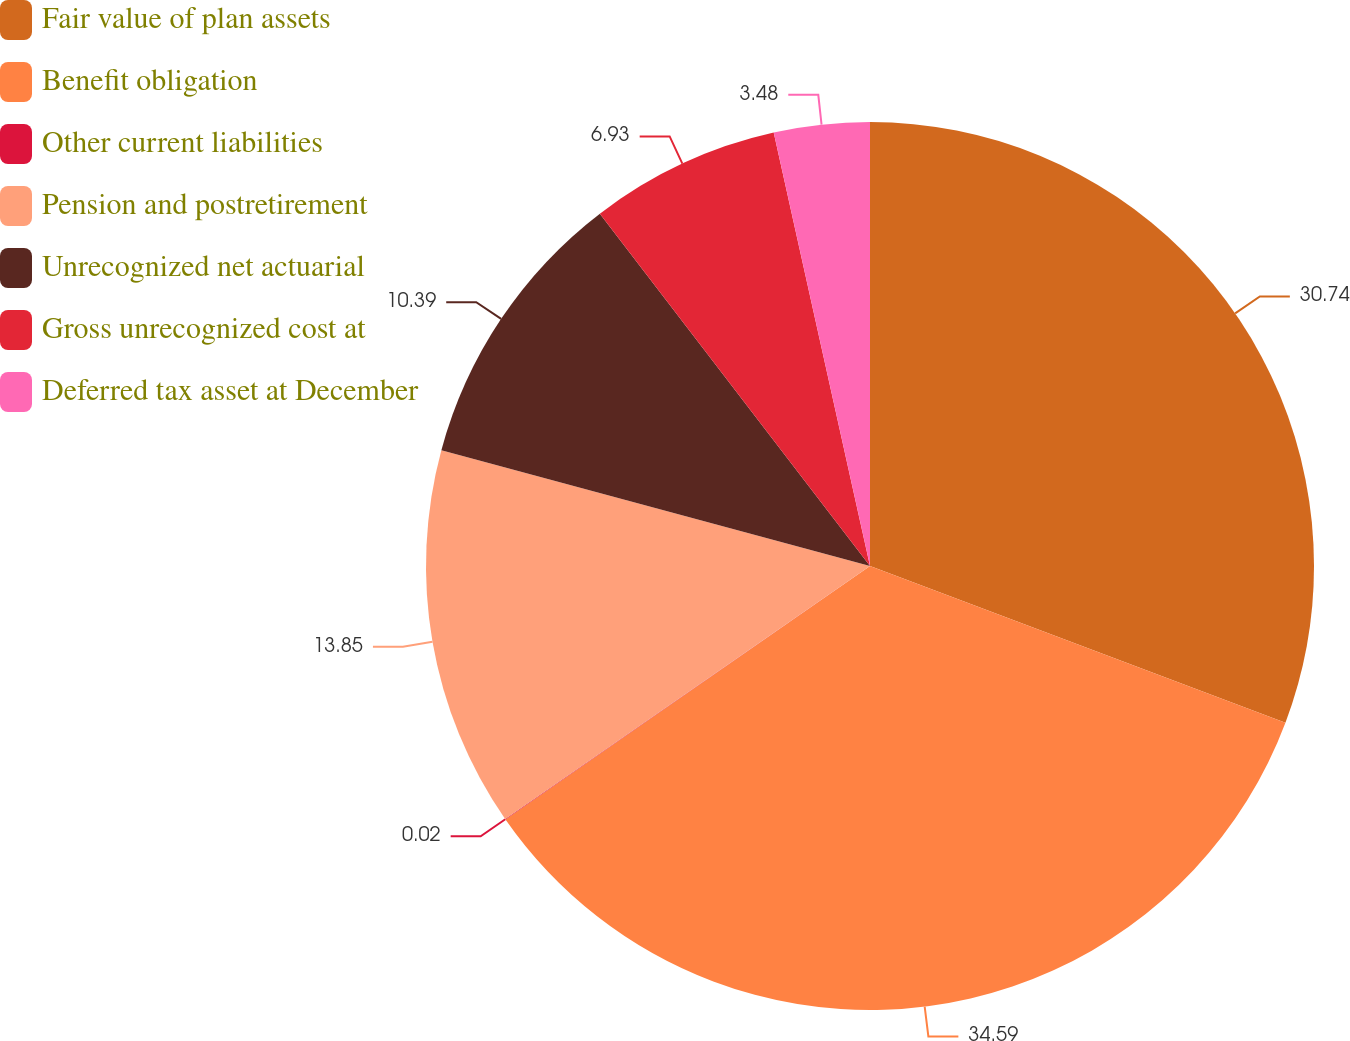Convert chart. <chart><loc_0><loc_0><loc_500><loc_500><pie_chart><fcel>Fair value of plan assets<fcel>Benefit obligation<fcel>Other current liabilities<fcel>Pension and postretirement<fcel>Unrecognized net actuarial<fcel>Gross unrecognized cost at<fcel>Deferred tax asset at December<nl><fcel>30.74%<fcel>34.59%<fcel>0.02%<fcel>13.85%<fcel>10.39%<fcel>6.93%<fcel>3.48%<nl></chart> 